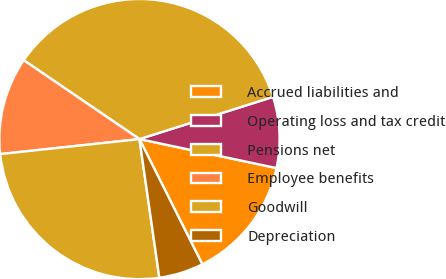Convert chart to OTSL. <chart><loc_0><loc_0><loc_500><loc_500><pie_chart><fcel>Accrued liabilities and<fcel>Operating loss and tax credit<fcel>Pensions net<fcel>Employee benefits<fcel>Goodwill<fcel>Depreciation<nl><fcel>14.28%<fcel>8.19%<fcel>35.61%<fcel>11.23%<fcel>25.56%<fcel>5.14%<nl></chart> 